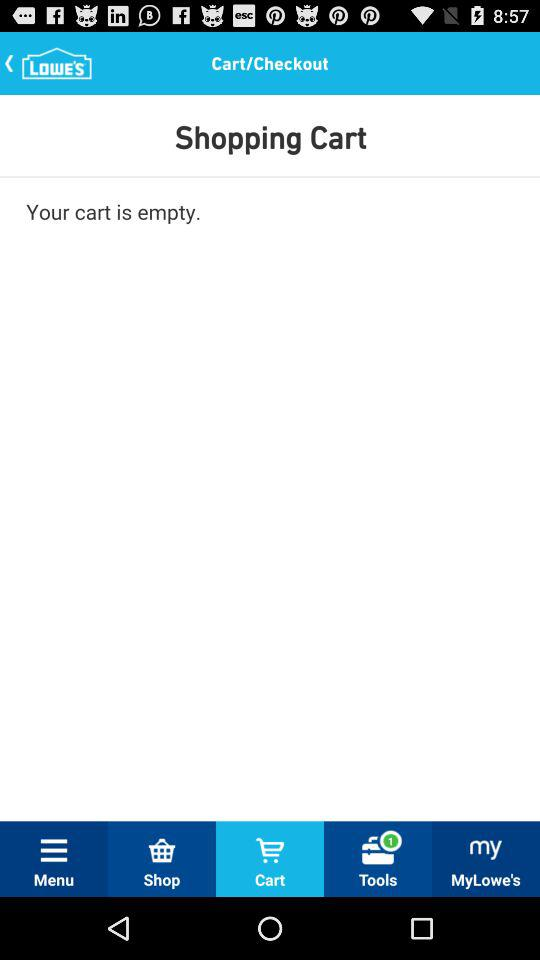What tab am I using? You are using the "Cart" tab. 